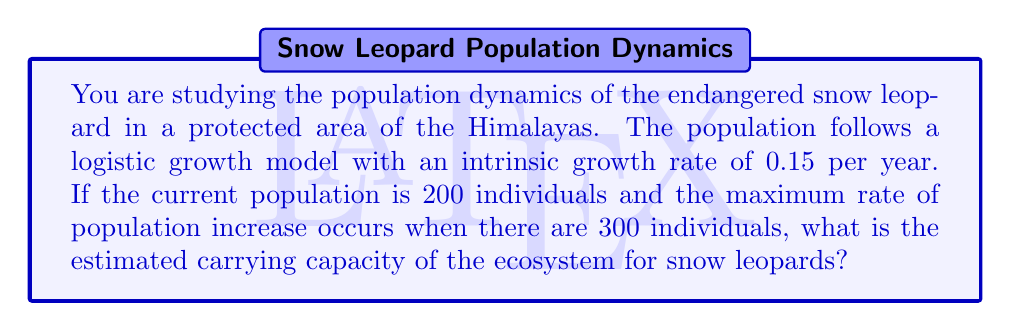What is the answer to this math problem? Let's approach this step-by-step using the logistic growth model:

1) The logistic growth equation is given by:

   $$\frac{dN}{dt} = rN(1 - \frac{N}{K})$$

   where $N$ is the population size, $r$ is the intrinsic growth rate, and $K$ is the carrying capacity.

2) The maximum rate of population increase occurs when $N = K/2$. We're given that this occurs when $N = 300$. Therefore:

   $$300 = \frac{K}{2}$$

3) Solving for $K$:

   $$K = 2 * 300 = 600$$

4) To verify, we can calculate the rate of change at this point:

   $$\frac{dN}{dt} = 0.15 * 300 * (1 - \frac{300}{600}) = 22.5$$

5) This is indeed the maximum rate, as it would be lower for both smaller and larger population sizes.

Therefore, the estimated carrying capacity of the ecosystem for snow leopards is 600 individuals.
Answer: 600 snow leopards 